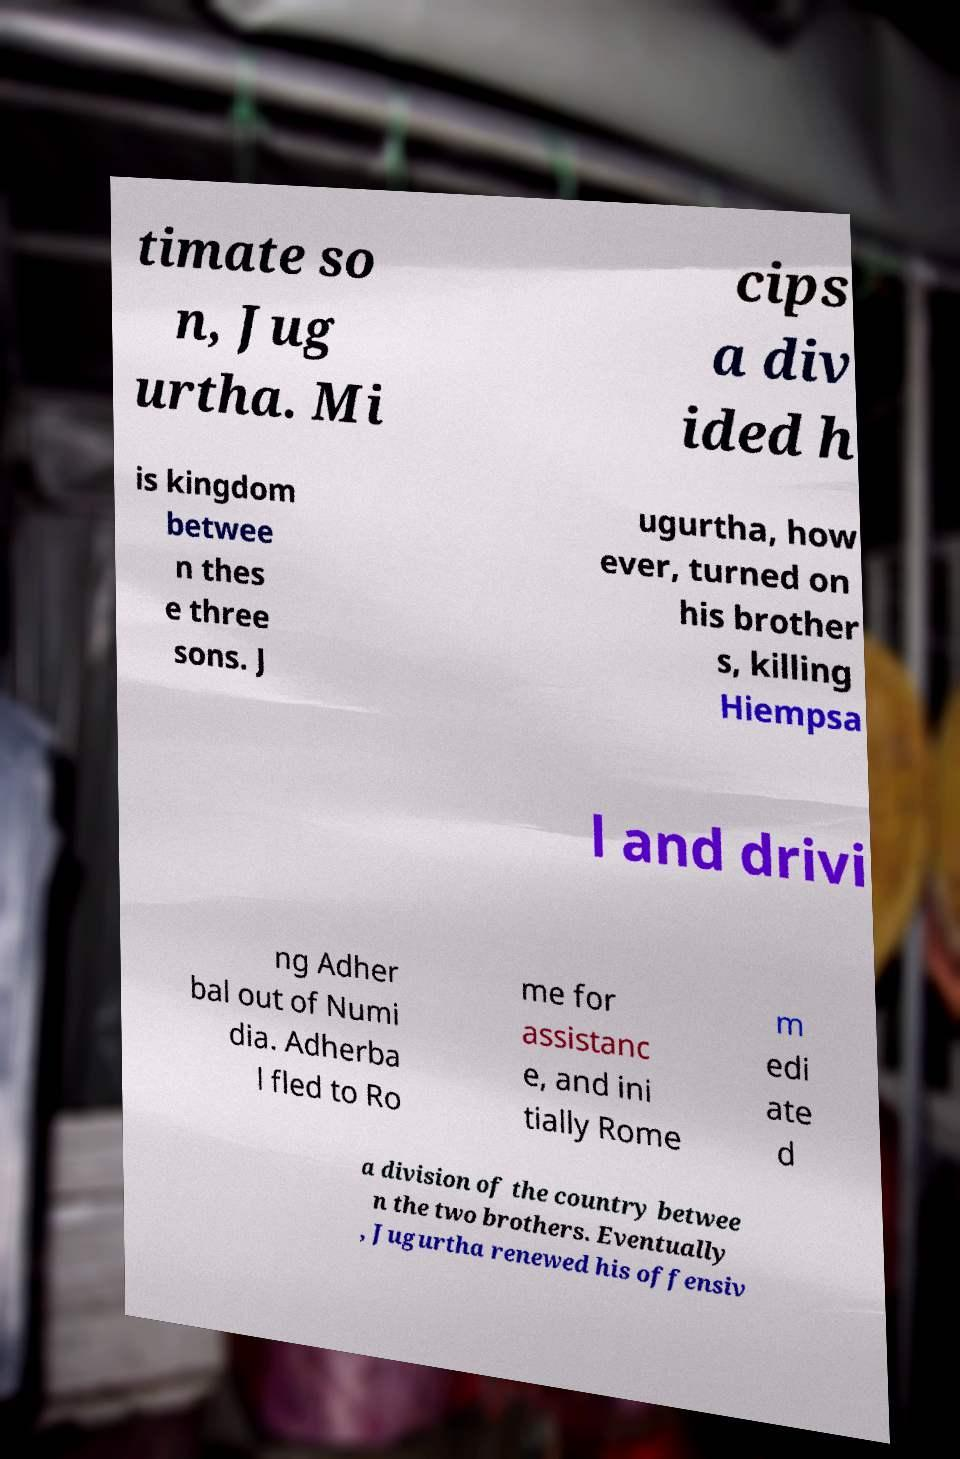For documentation purposes, I need the text within this image transcribed. Could you provide that? timate so n, Jug urtha. Mi cips a div ided h is kingdom betwee n thes e three sons. J ugurtha, how ever, turned on his brother s, killing Hiempsa l and drivi ng Adher bal out of Numi dia. Adherba l fled to Ro me for assistanc e, and ini tially Rome m edi ate d a division of the country betwee n the two brothers. Eventually , Jugurtha renewed his offensiv 